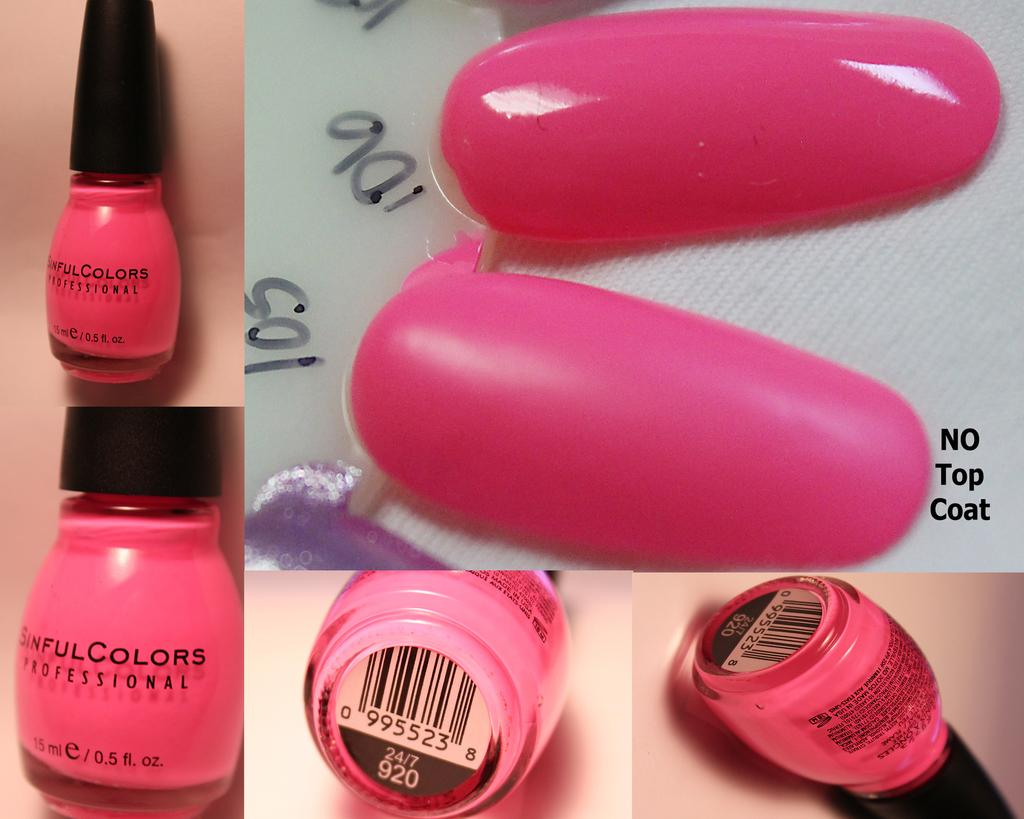<image>
Write a terse but informative summary of the picture. A bottle of bright pink Sinful Colors Professional nail polish. 